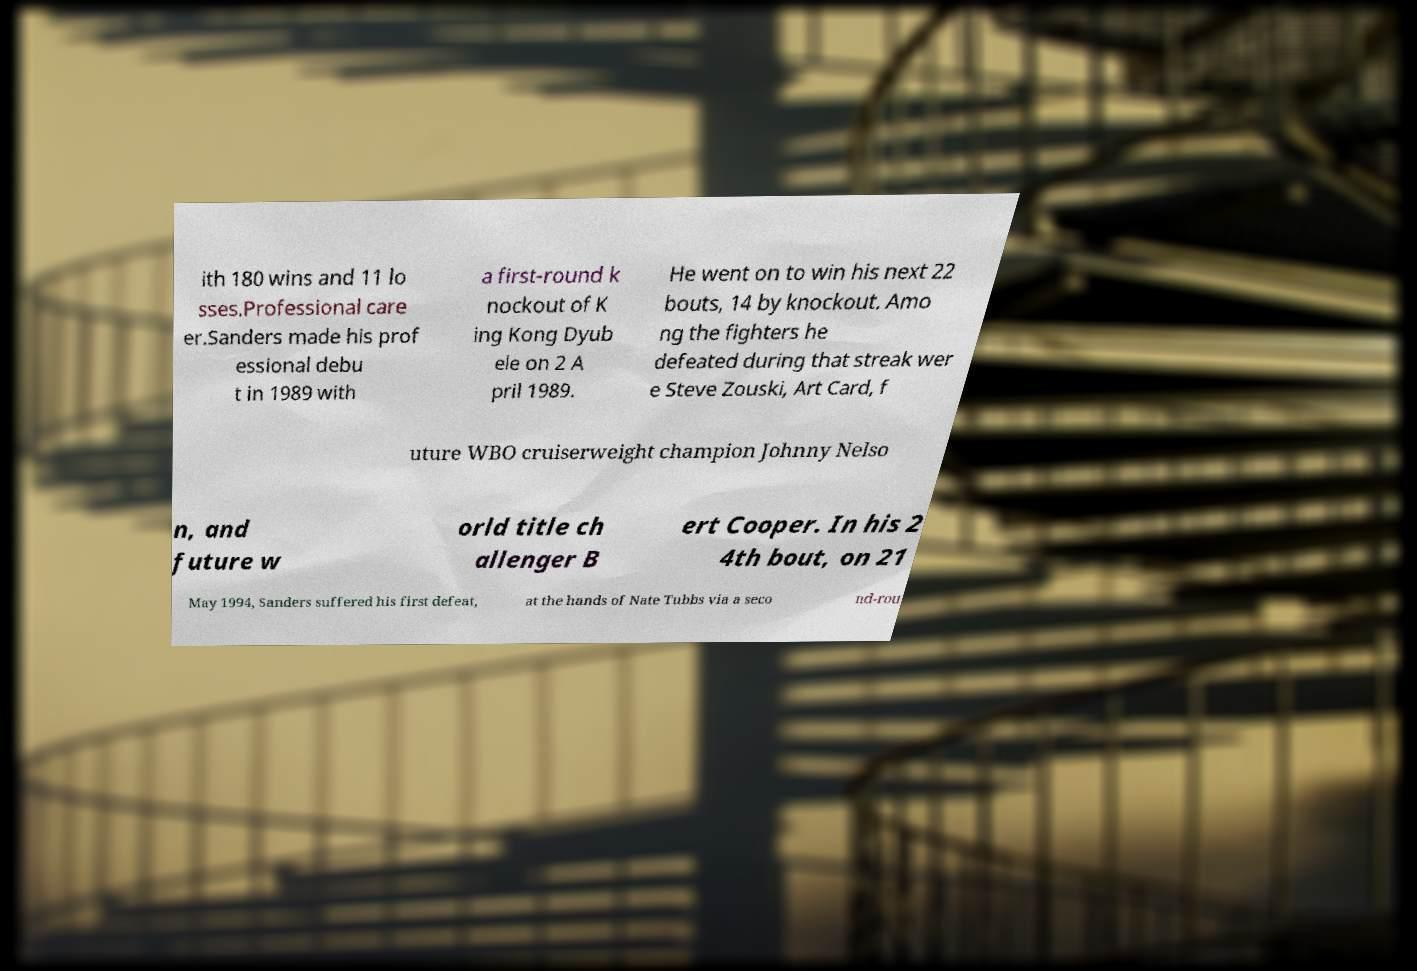I need the written content from this picture converted into text. Can you do that? ith 180 wins and 11 lo sses.Professional care er.Sanders made his prof essional debu t in 1989 with a first-round k nockout of K ing Kong Dyub ele on 2 A pril 1989. He went on to win his next 22 bouts, 14 by knockout. Amo ng the fighters he defeated during that streak wer e Steve Zouski, Art Card, f uture WBO cruiserweight champion Johnny Nelso n, and future w orld title ch allenger B ert Cooper. In his 2 4th bout, on 21 May 1994, Sanders suffered his first defeat, at the hands of Nate Tubbs via a seco nd-rou 